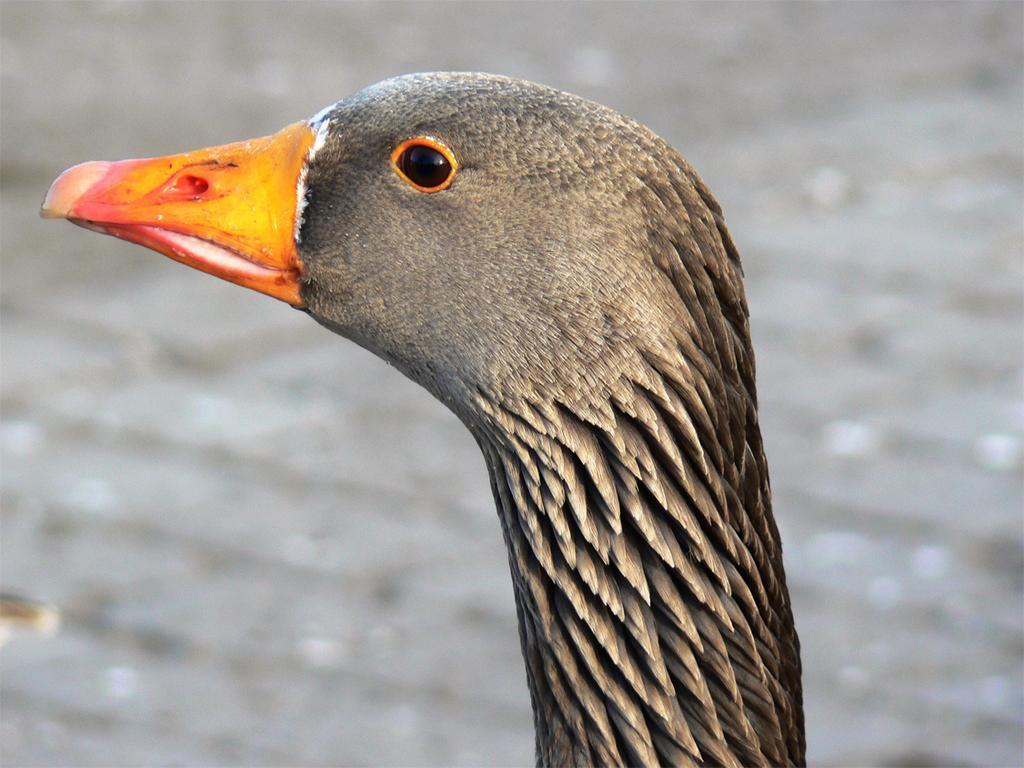Could you give a brief overview of what you see in this image? In this image we can see the head of a goose. In the background of the image there is a blur background. 